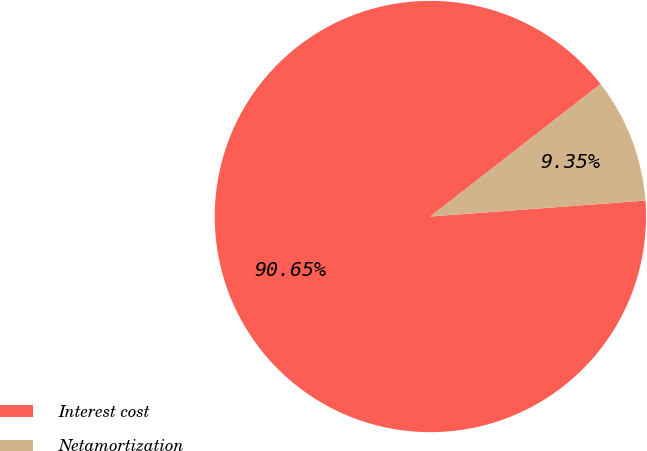Convert chart to OTSL. <chart><loc_0><loc_0><loc_500><loc_500><pie_chart><fcel>Interest cost<fcel>Netamortization<nl><fcel>90.65%<fcel>9.35%<nl></chart> 